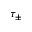<formula> <loc_0><loc_0><loc_500><loc_500>\tau _ { \pm }</formula> 